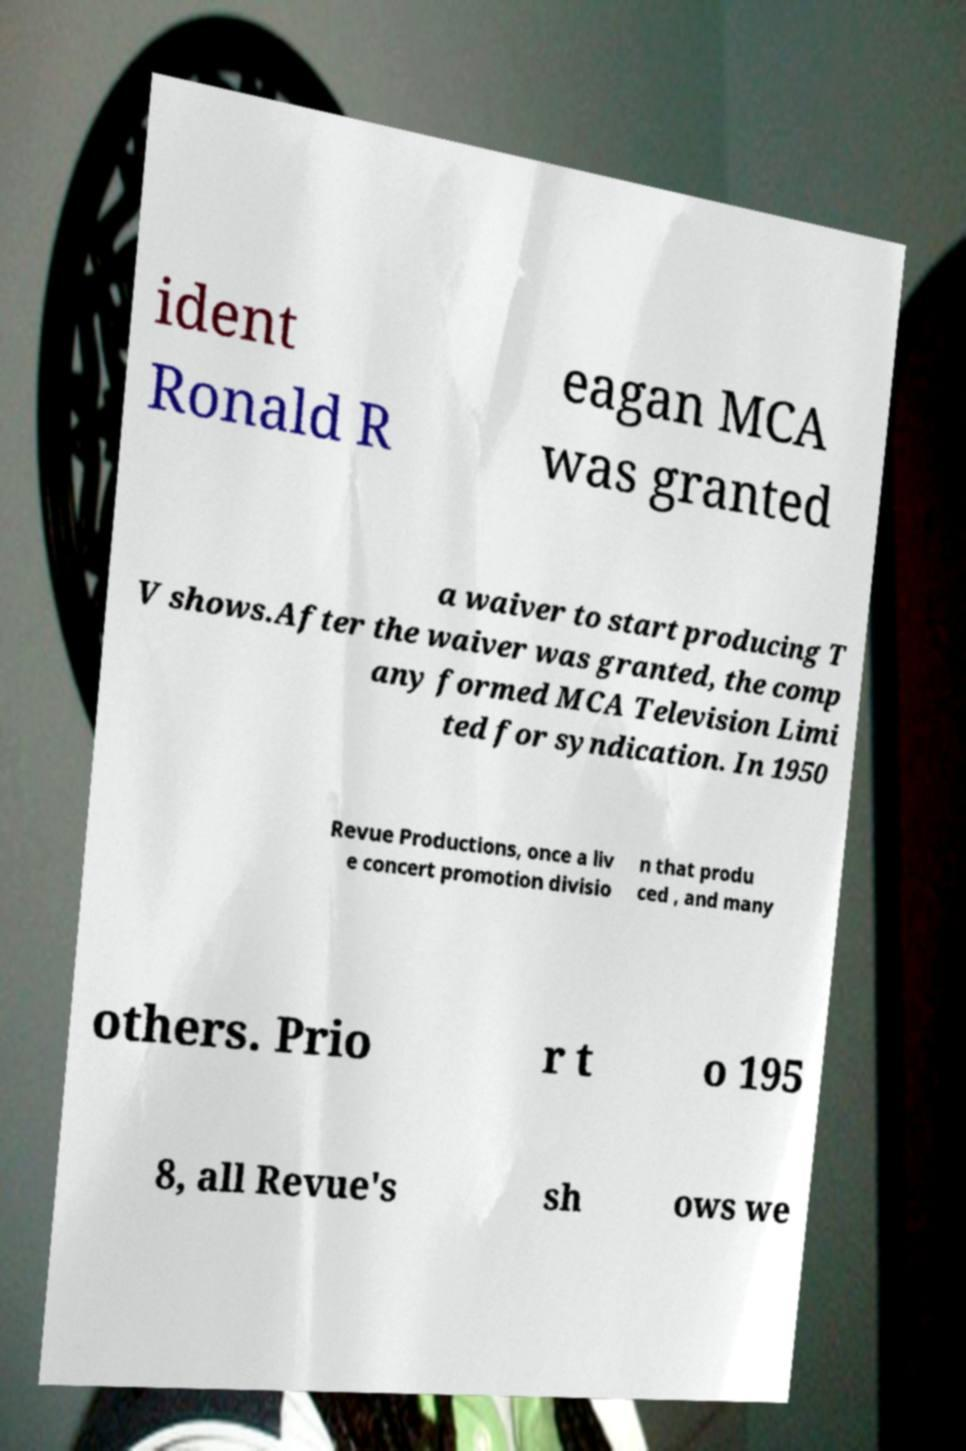Please identify and transcribe the text found in this image. ident Ronald R eagan MCA was granted a waiver to start producing T V shows.After the waiver was granted, the comp any formed MCA Television Limi ted for syndication. In 1950 Revue Productions, once a liv e concert promotion divisio n that produ ced , and many others. Prio r t o 195 8, all Revue's sh ows we 